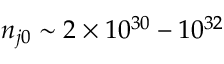Convert formula to latex. <formula><loc_0><loc_0><loc_500><loc_500>n _ { j 0 } \sim 2 \times 1 0 ^ { 3 0 } - 1 0 ^ { 3 2 }</formula> 